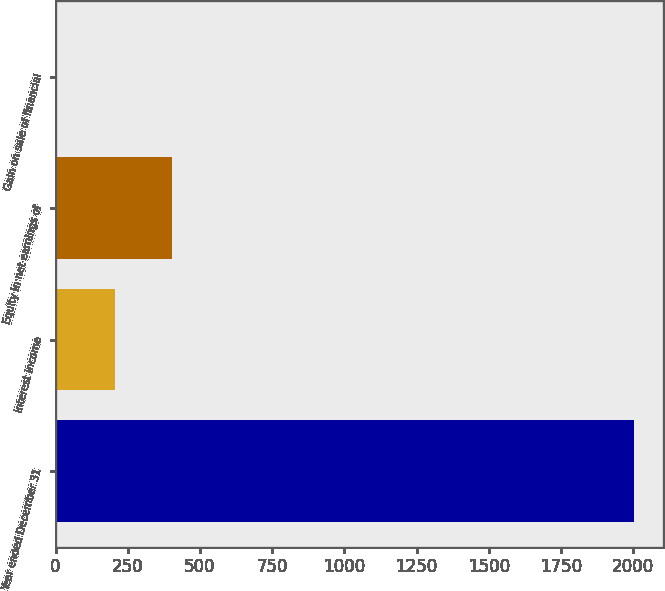<chart> <loc_0><loc_0><loc_500><loc_500><bar_chart><fcel>Year ended December 31<fcel>Interest income<fcel>Equity in net earnings of<fcel>Gain on sale of financial<nl><fcel>2003<fcel>204.8<fcel>404.6<fcel>5<nl></chart> 